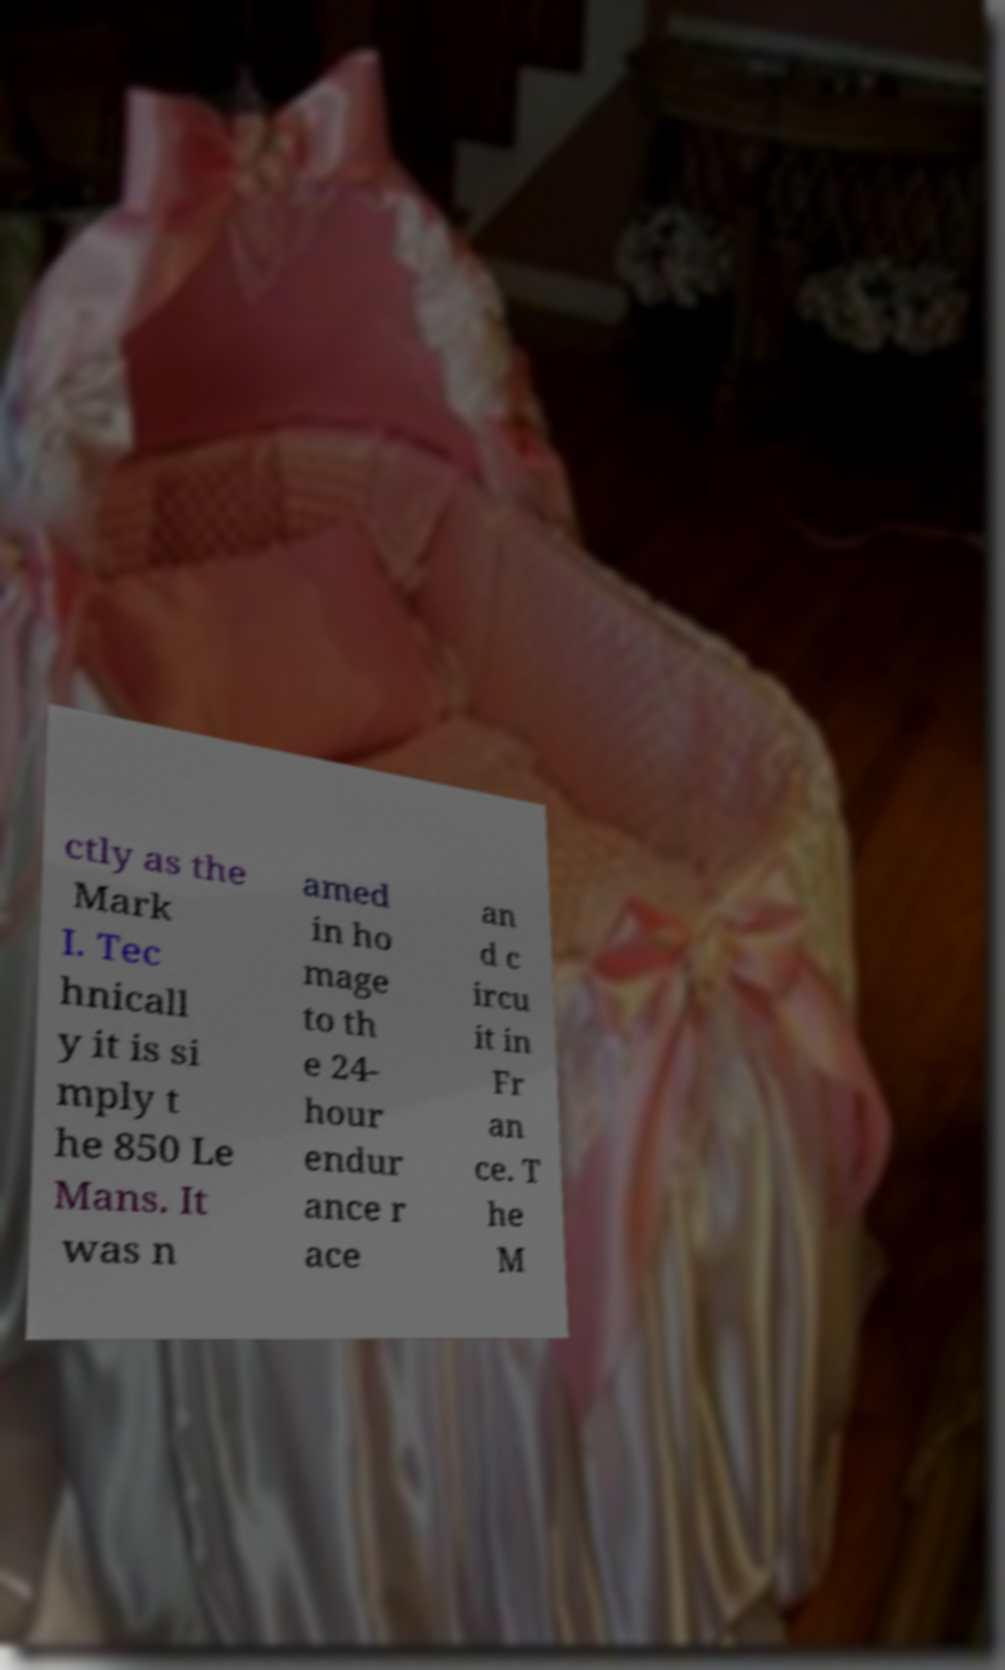I need the written content from this picture converted into text. Can you do that? ctly as the Mark I. Tec hnicall y it is si mply t he 850 Le Mans. It was n amed in ho mage to th e 24- hour endur ance r ace an d c ircu it in Fr an ce. T he M 